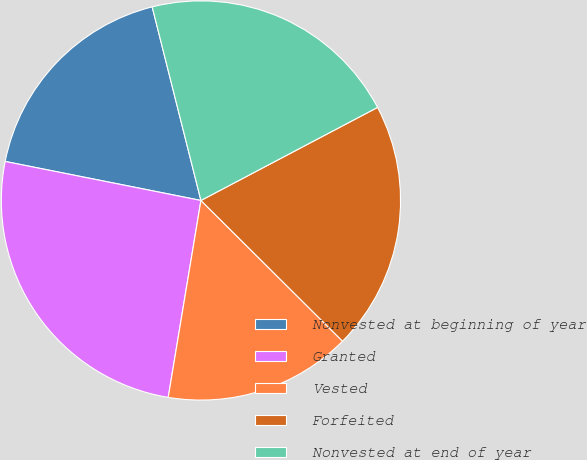Convert chart to OTSL. <chart><loc_0><loc_0><loc_500><loc_500><pie_chart><fcel>Nonvested at beginning of year<fcel>Granted<fcel>Vested<fcel>Forfeited<fcel>Nonvested at end of year<nl><fcel>17.94%<fcel>25.51%<fcel>15.17%<fcel>20.17%<fcel>21.21%<nl></chart> 